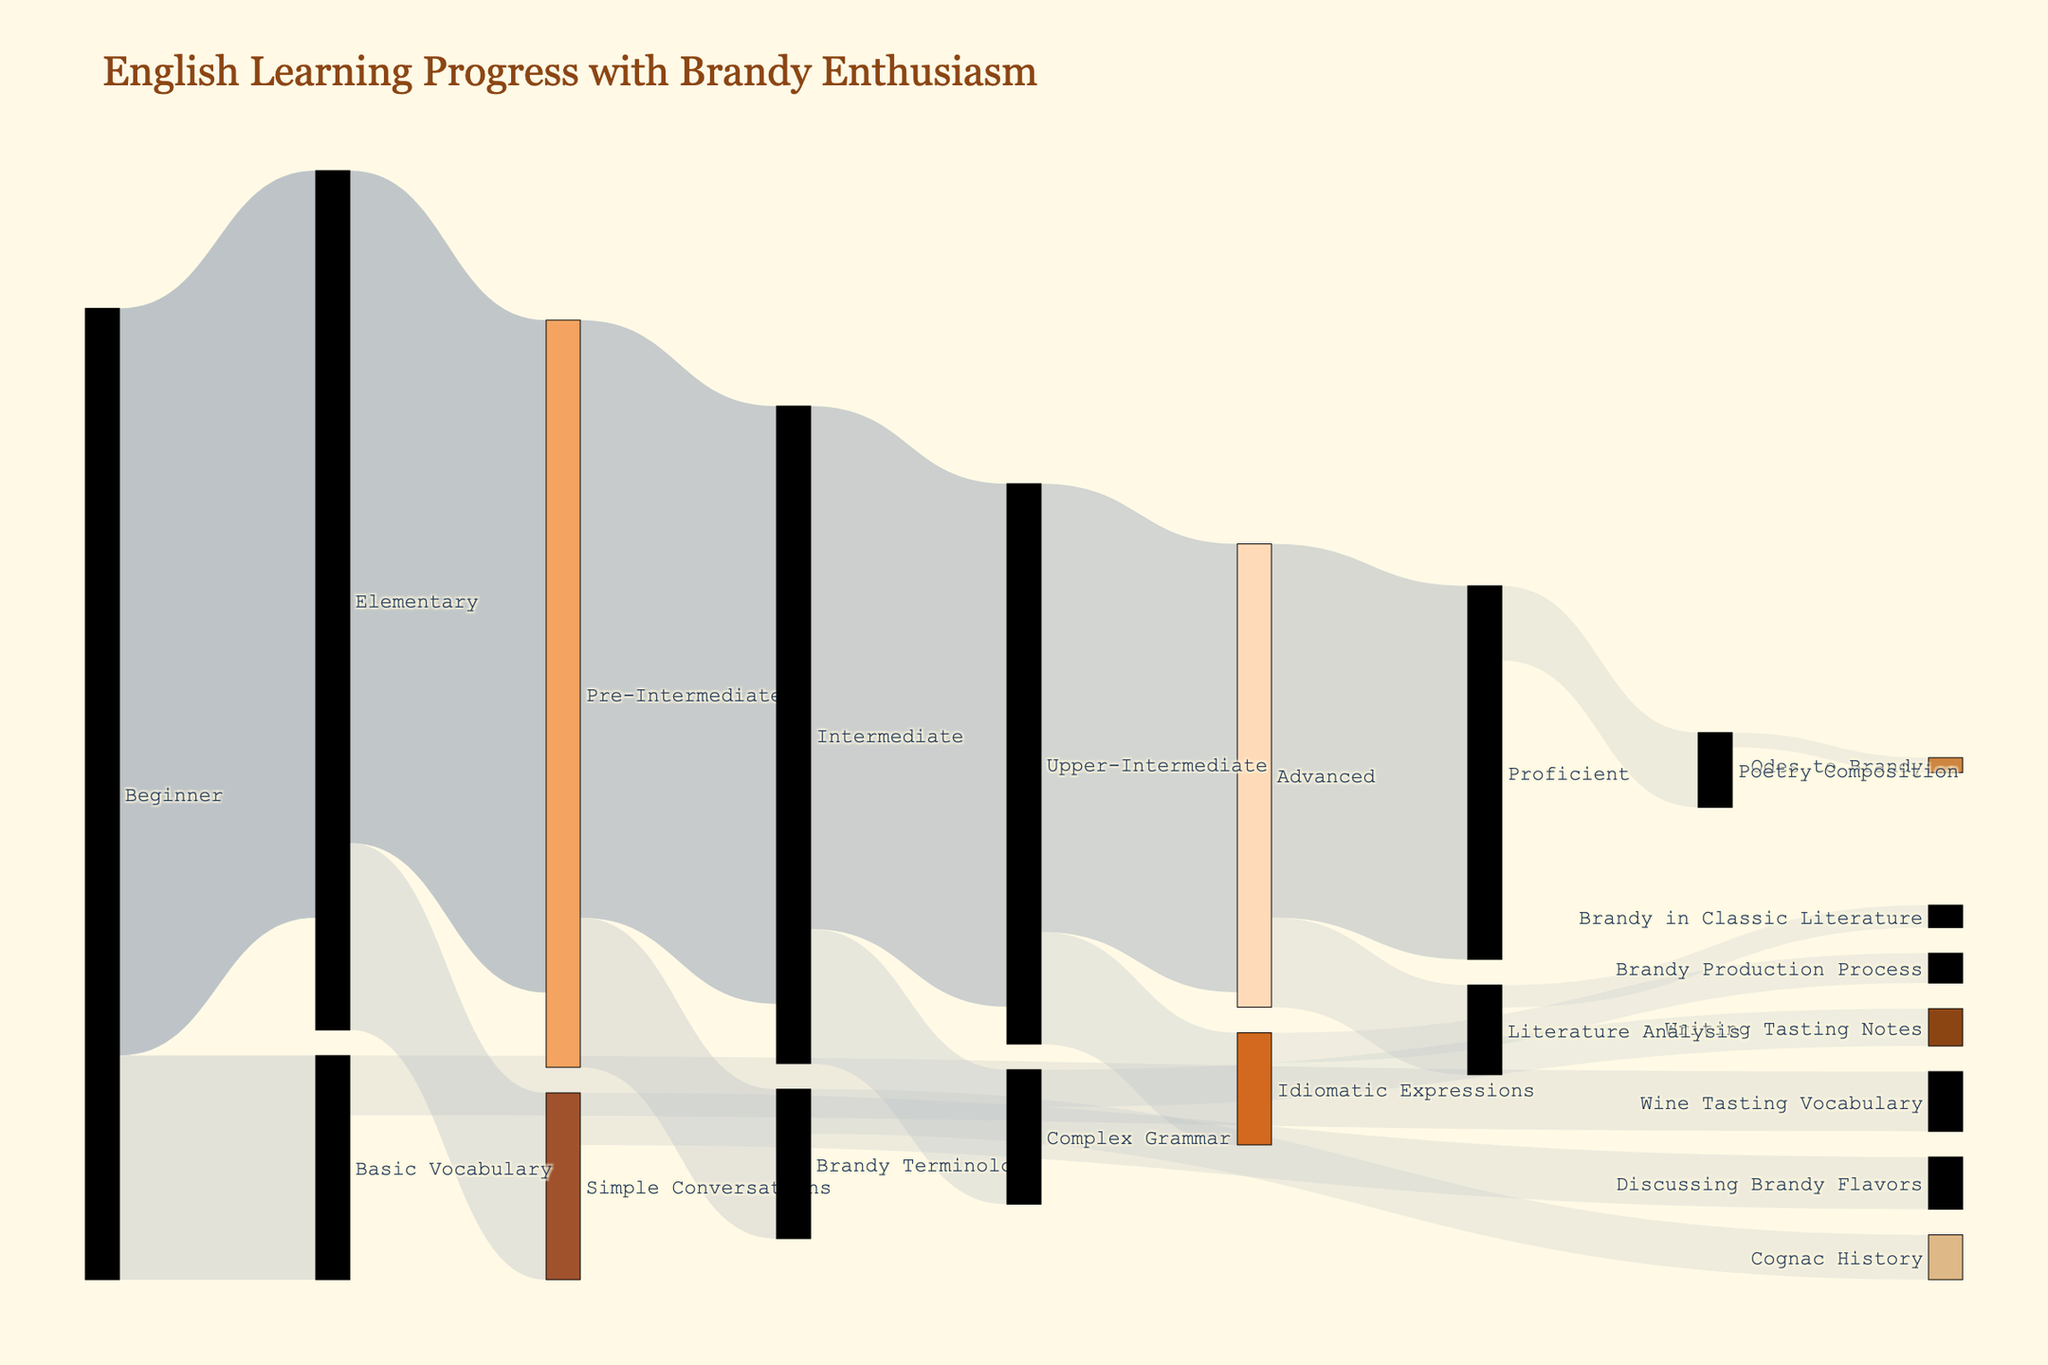Which level has the highest progression to the next level in terms of number of learners? To determine this, look for the link with the highest value connecting two levels. The link from Beginner to Elementary has the highest value at 100.
Answer: Beginner to Elementary Which level transitions directly to "Idiomatic Expressions"? To identify this, look at the node that links directly to "Idiomatic Expressions." "Upper-Intermediate" has a link going directly to "Idiomatic Expressions."
Answer: Upper-Intermediate How many learners progress from "Pre-Intermediate" to "Intermediate"? Check the link value between "Pre-Intermediate" and "Intermediate." The value is 80.
Answer: 80 What is the total number of learners that reach the "Proficient" level? Identify the total value flowing into "Proficient" by summing up the values of all incoming links. Only "Proficient" receives 50 learners from "Advanced."
Answer: 50 How many skills are acquired at the "Intermediate" level? Count the number of links flowing from "Intermediate" to various skills. The skills linked from "Intermediate" are "Complex Grammar," which makes a total of 1.
Answer: 1 Which skill related to Brandy can be acquired from "Pre-Intermediate"? Focus on the link originating from "Pre-Intermediate" that leads to a skill node. "Pre-Intermediate" links to "Brandy Terminology."
Answer: Brandy Terminology Is the progression value from "Elementary" to "Pre-Intermediate" greater than from "Advanced" to "Proficient"? Compare the link values between "Elementary" to "Pre-Intermediate" (90) and "Advanced" to "Proficient" (50). 90 is greater than 50.
Answer: Yes Which two levels have a progression value difference of 20 learners? Calculate the difference between the progression values among the levels and find those with a difference of 20. The levels with a difference of 20 are "Pre-Intermediate" to "Intermediate" (80) and "Upper-Intermediate" to "Advanced" (60).
Answer: Pre-Intermediate to Intermediate and Upper-Intermediate to Advanced What is the combined total of learners progressing from "Intermediate" to other levels and skills? Add the values of all links originating from "Intermediate." They are 70 (to Upper-Intermediate) and 18 (to Complex Grammar), so 70 + 18 = 88.
Answer: 88 How many skills involve Brandy-related terminology or activities? Identify all skills that mention Brandy-related terms or activities: "Brandy Terminology," "Wine Tasting Vocabulary," "Discussing Brandy Flavors," "Cognac History," "Writing Tasting Notes," "Brandy Production Process," and "Brandy in Classic Literature." There are 7 such skills.
Answer: 7 